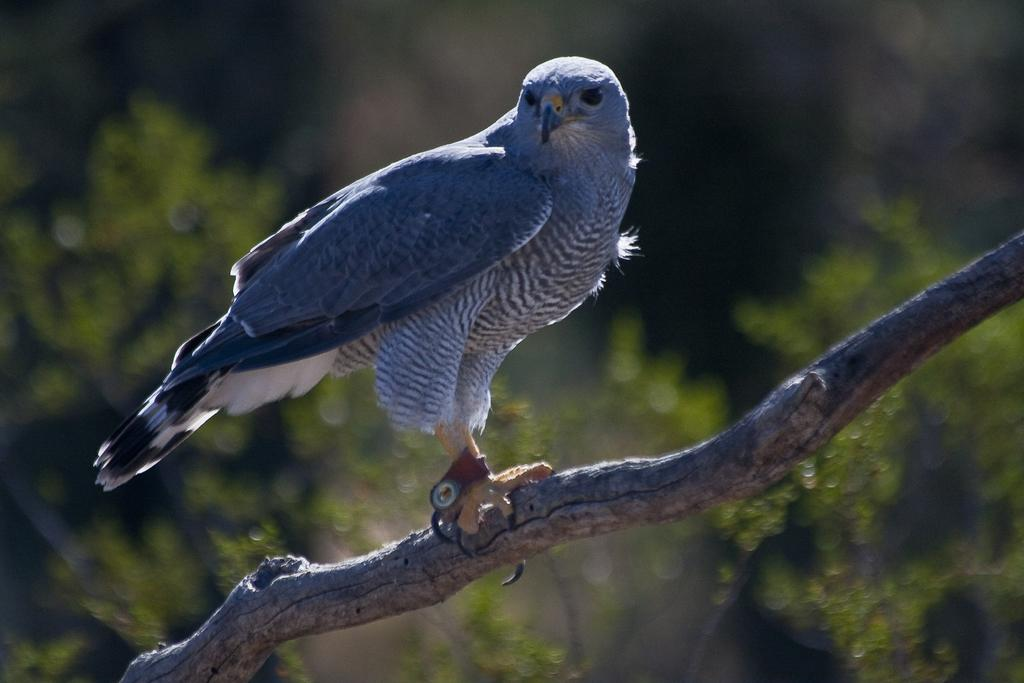What type of animal is in the image? There is a bird in the image. Where is the bird located? The bird is on a branch. What can be seen in the background of the image? The background of the image is blurred, and there is greenery visible. How many kittens are sitting on the chair in the image? There are no kittens or chairs present in the image. What type of stem is visible in the image? There is no stem visible in the image. 